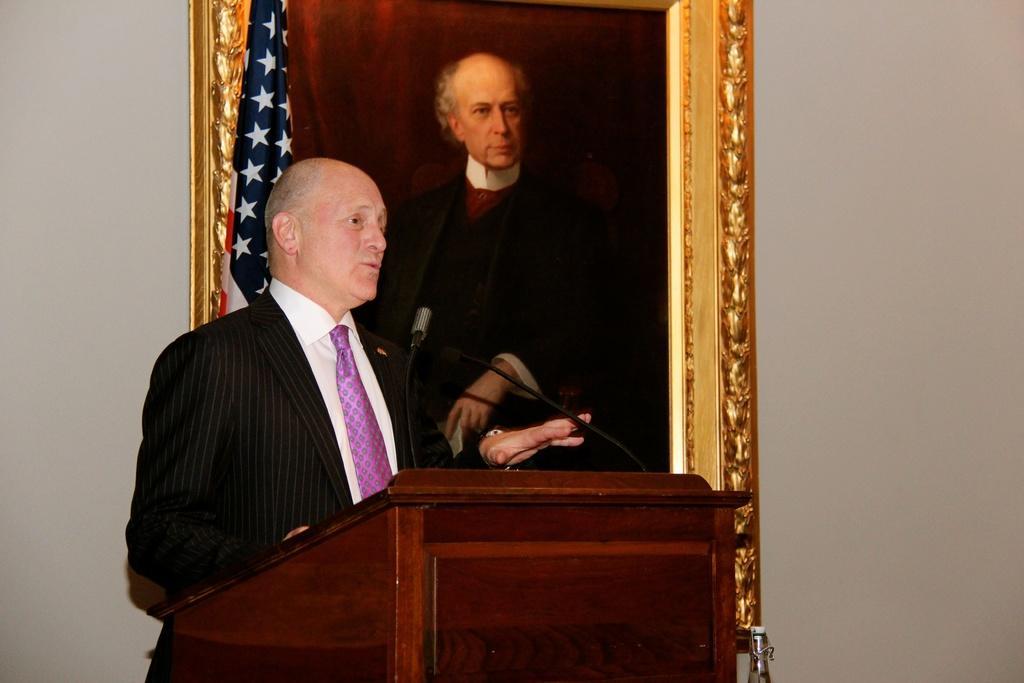Can you describe this image briefly? In this image, we can see a person in front of the podium. There is a photo frame on the wall. There is a flag at the top of the image. 